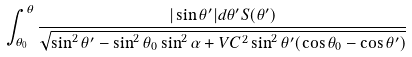Convert formula to latex. <formula><loc_0><loc_0><loc_500><loc_500>\int _ { \theta _ { 0 } } ^ { \theta } \frac { | \sin \theta ^ { \prime } | d \theta ^ { \prime } S ( \theta ^ { \prime } ) } { \sqrt { \sin ^ { 2 } \theta ^ { \prime } - \sin ^ { 2 } \theta _ { 0 } \sin ^ { 2 } \alpha + V C ^ { 2 } \sin ^ { 2 } \theta ^ { \prime } ( \cos \theta _ { 0 } - \cos \theta ^ { \prime } ) } }</formula> 